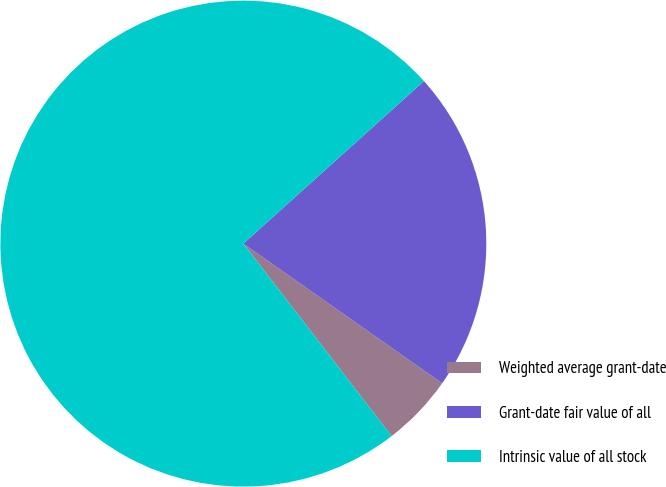<chart> <loc_0><loc_0><loc_500><loc_500><pie_chart><fcel>Weighted average grant-date<fcel>Grant-date fair value of all<fcel>Intrinsic value of all stock<nl><fcel>4.81%<fcel>21.41%<fcel>73.78%<nl></chart> 